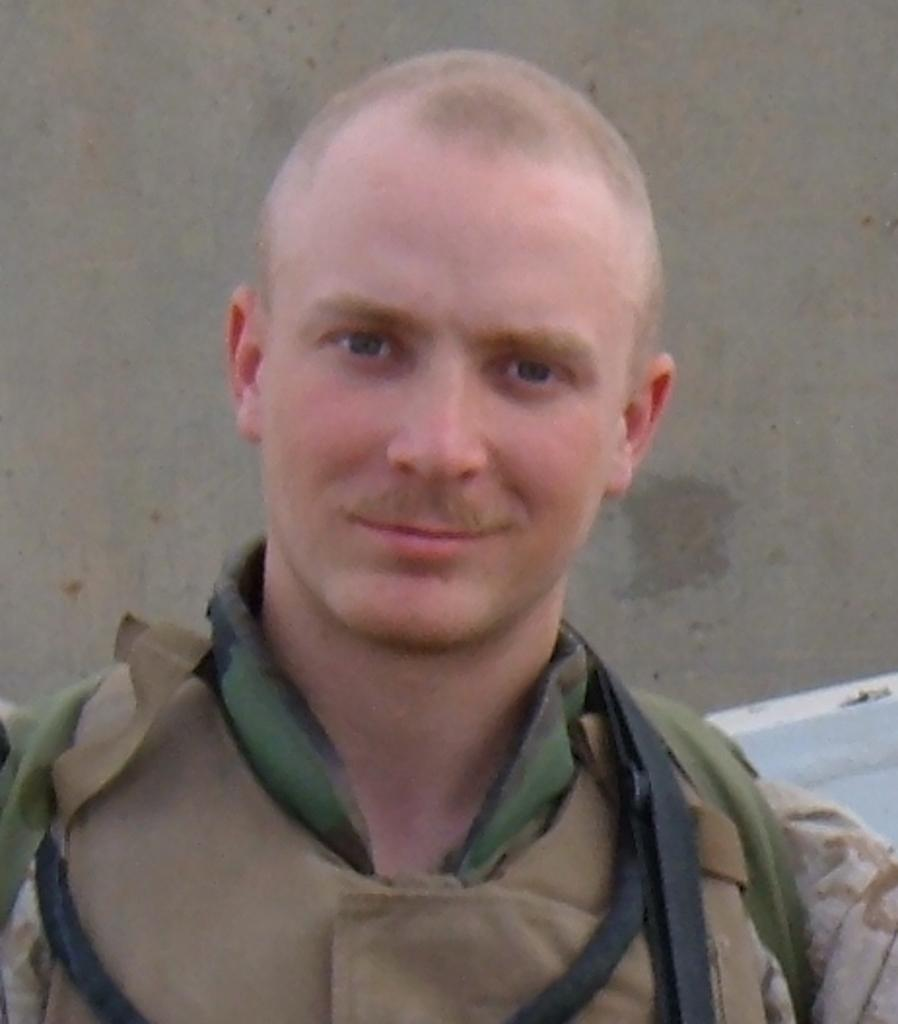What is the main subject in the foreground of the picture? There is a soldier in the foreground of the picture. What is the soldier doing in the picture? The soldier is smiling. What can be seen in the background of the picture? There is a wall behind the soldier. What type of education is the soldier attending in the picture? There is no indication in the image that the soldier is attending any educational institution. How many dogs are visible in the picture? There are no dogs present in the image. 